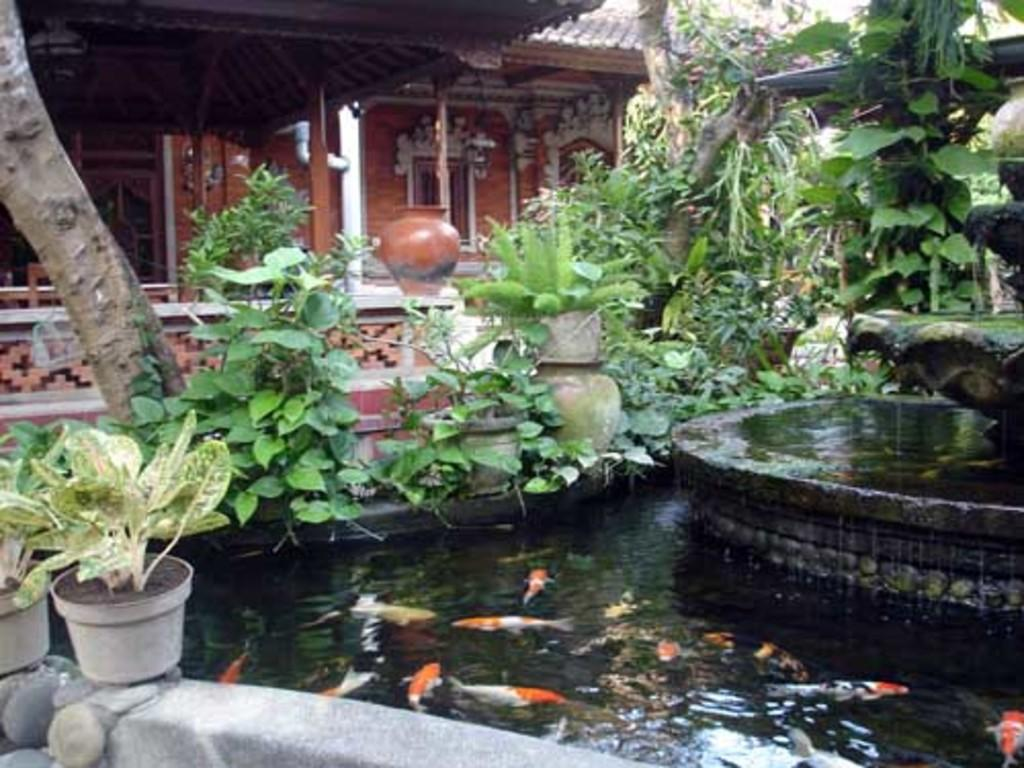What is the primary element in the image? There is water in the image. What can be seen in the water? There are fishes in the water. What type of structure is present in the image? There is a water fountain in the image. What type of vegetation is present in the image? House plants and trees are visible in the image. What type of buildings can be seen in the background of the image? There are sheds and a house in the background of the image. What other objects can be seen in the background of the image? There is a pot in the background of the image. What color is the orange that is being transported by the truck in the image? There is no orange or truck present in the image. What type of suit is the person wearing while standing near the house in the image? There is no person or suit present in the image. 